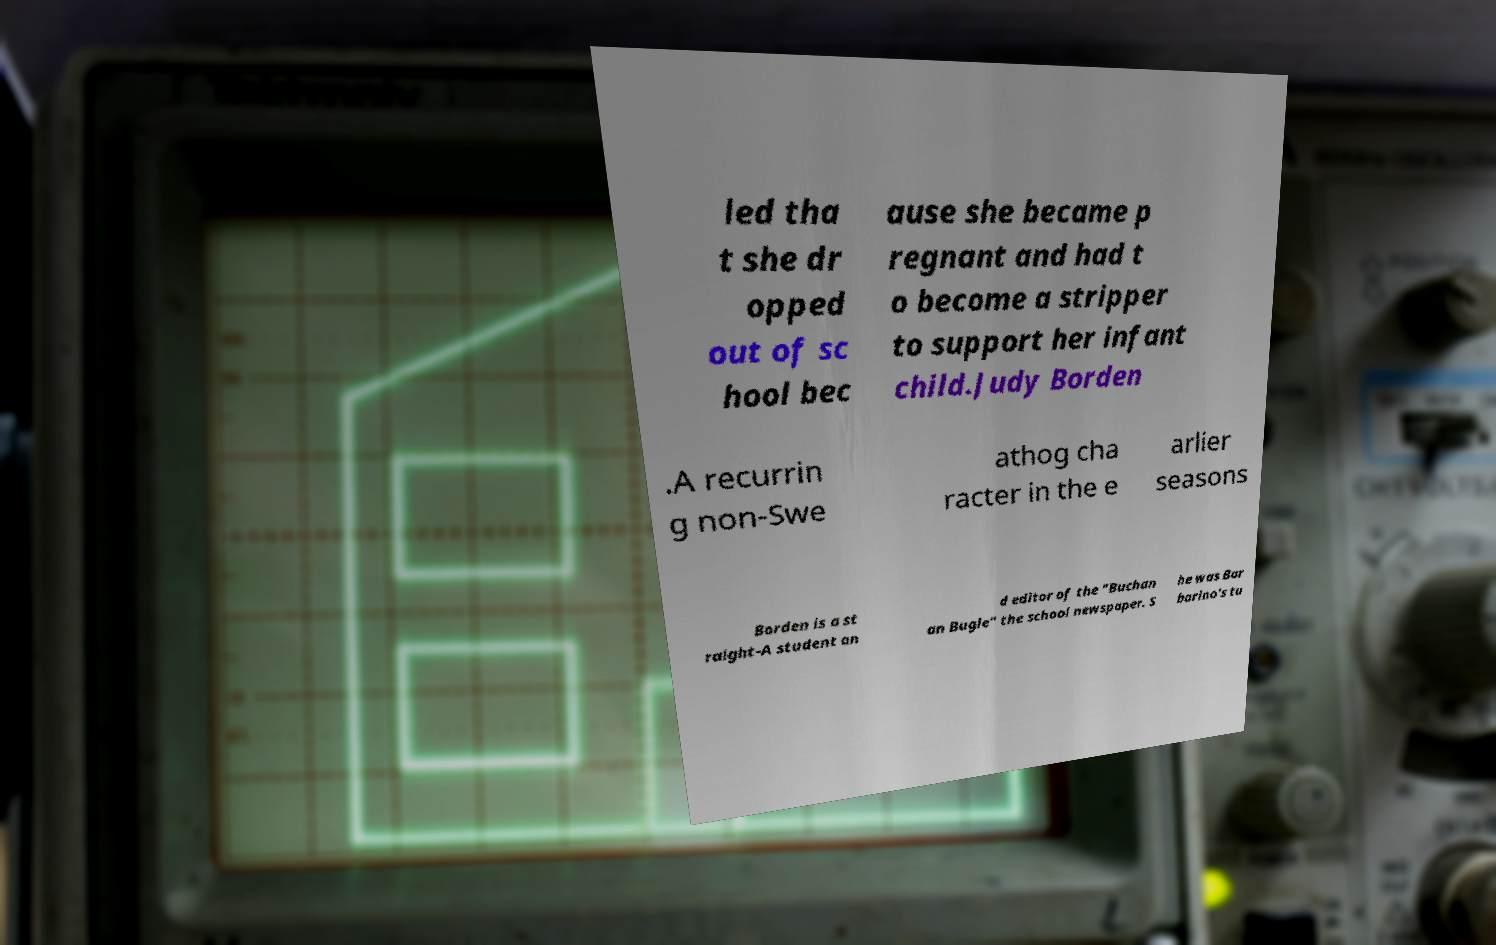Can you accurately transcribe the text from the provided image for me? led tha t she dr opped out of sc hool bec ause she became p regnant and had t o become a stripper to support her infant child.Judy Borden .A recurrin g non-Swe athog cha racter in the e arlier seasons Borden is a st raight-A student an d editor of the "Buchan an Bugle" the school newspaper. S he was Bar barino's tu 